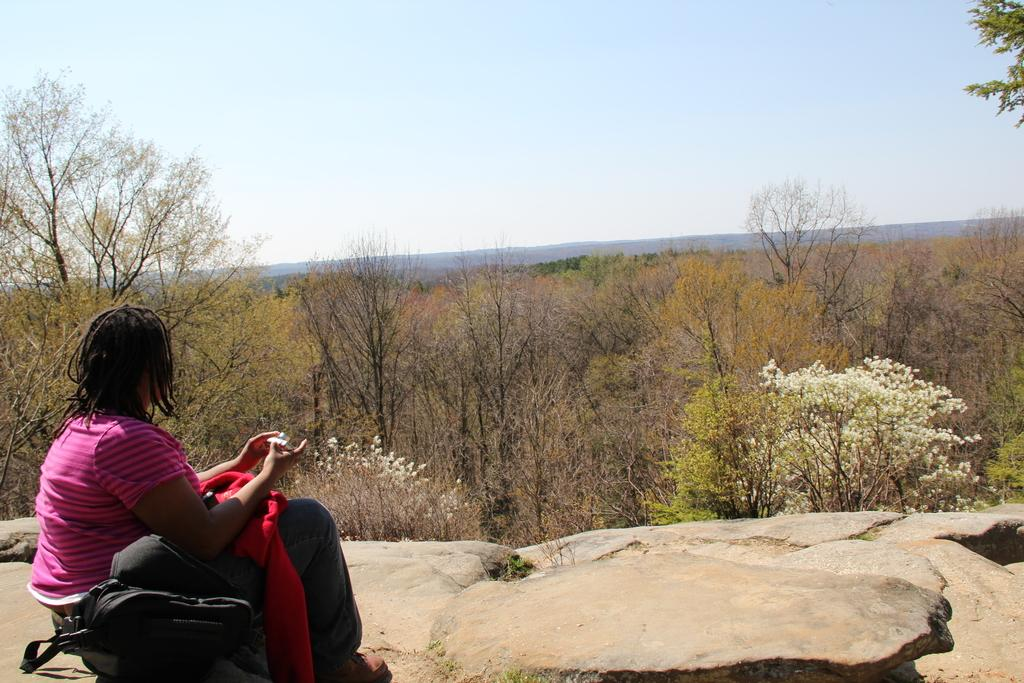What is the woman doing in the image? The woman is sitting on a stone in the image. What object is beside the woman? There is a black color bag beside the woman. What type of natural environment is visible in the image? There are trees visible in the image. What is visible above the trees and the woman? The sky is visible in the image. What type of teeth can be seen in the image? There are no teeth visible in the image. 